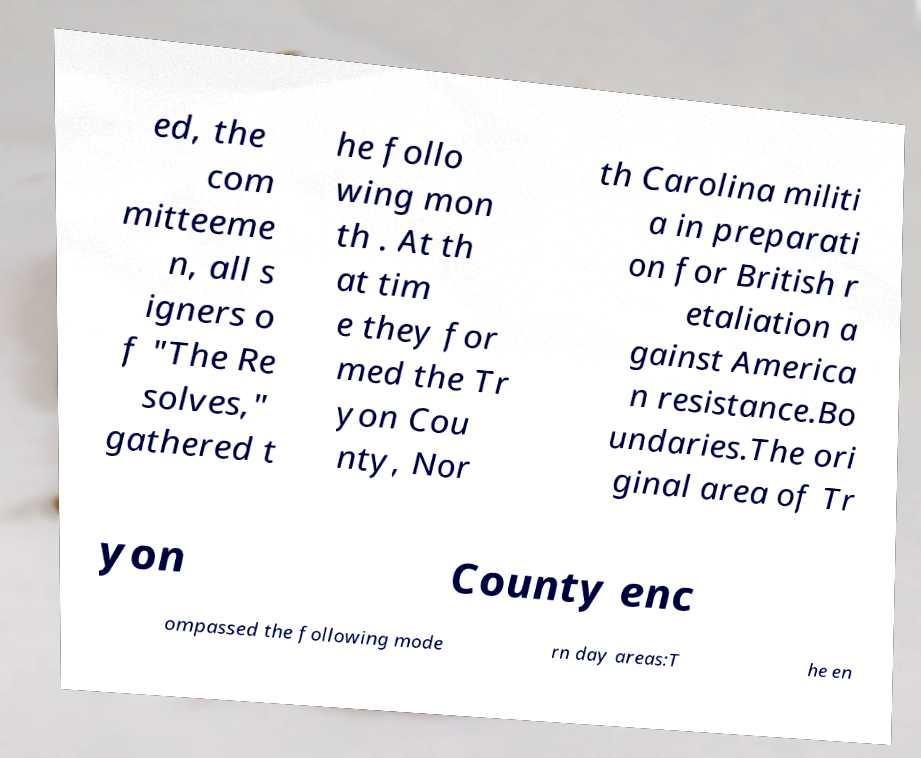There's text embedded in this image that I need extracted. Can you transcribe it verbatim? ed, the com mitteeme n, all s igners o f "The Re solves," gathered t he follo wing mon th . At th at tim e they for med the Tr yon Cou nty, Nor th Carolina militi a in preparati on for British r etaliation a gainst America n resistance.Bo undaries.The ori ginal area of Tr yon County enc ompassed the following mode rn day areas:T he en 